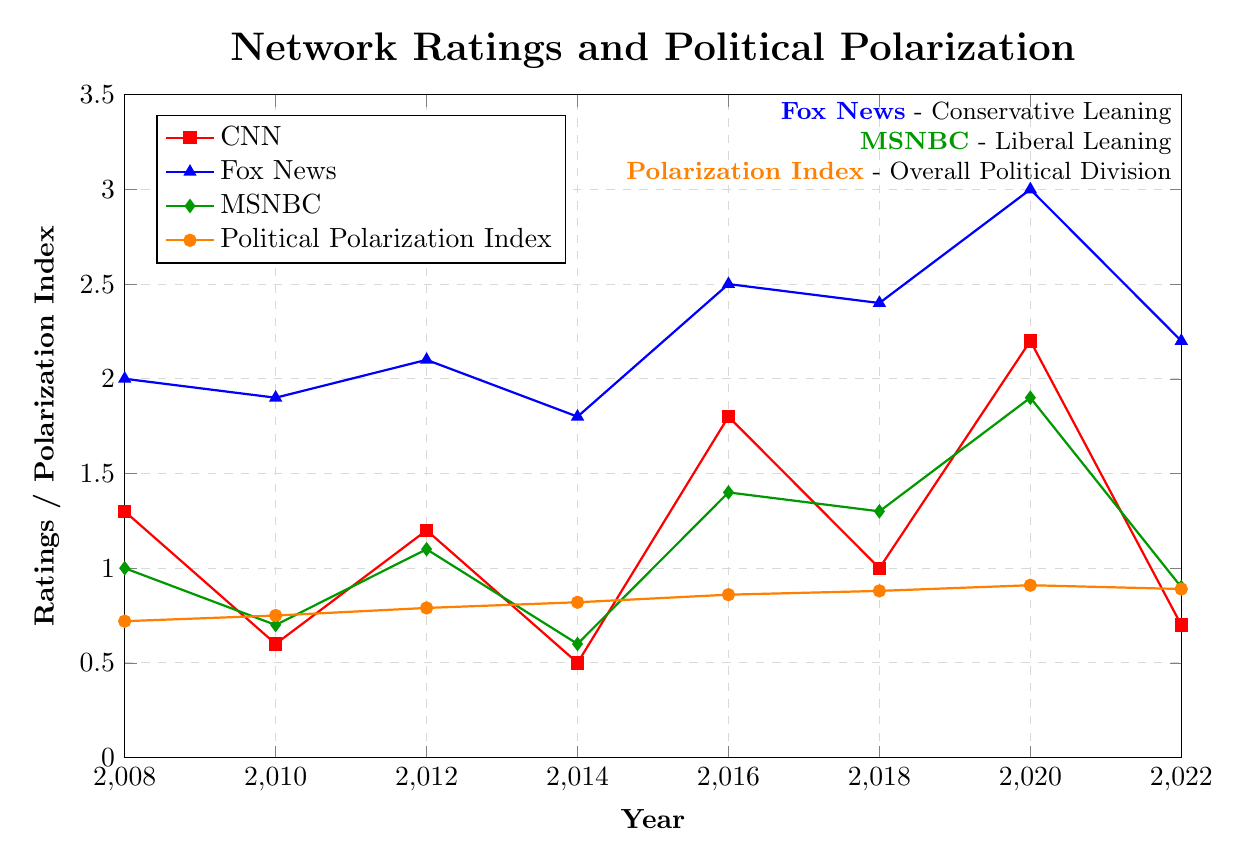What year had the highest CNN rating? By looking at the red line representing CNN in the plot, we notice that the CNN rating peaked in 2020.
Answer: 2020 Which network had the lowest ratings in 2014? Observing the ratings for 2014, CNN (0.5) and MSNBC (0.6) both have low ratings, but CNN's rating is the lowest.
Answer: CNN How does the trend of Fox News ratings compare to the Political Polarization Index? Examining both the blue line for Fox News and the orange line for the Political Polarization Index, both show an increasing trend from 2008 to 2020 with a slight decrease in 2022, indicating a similar upward trajectory.
Answer: Similar upward trend In which year did CNN ratings and MSNBC ratings have the same relative difference as in 2022? Calculate the relative difference between CNN and MSNBC ratings in 2022 (0.7 - 0.9 = -0.2). Then, compare this difference with other years to find that in 2008 (1.3 - 1.0 = 0.3) is close, though not identical. Therefore, 2022 doesn't have an exact match earlier years show a difference.
Answer: No exact match What is the average rating of MSNBC between 2008 and 2018? Summing up MSNBC's ratings from 2008 to 2018: 1.0 + 0.7 + 1.1 + 0.6 + 1.4 + 1.3 = 6.1. There are 6 years, so the average rating is 6.1 / 6 = 1.02.
Answer: 1.02 Which network had the greatest increase in ratings from 2008 to 2020? Calculate the difference in ratings from 2008 to 2020 for each network: CNN (2.2 - 1.3 = 0.9), Fox News (3.0 - 2.0 = 1.0), and MSNBC (1.9 - 1.0 = 0.9). Fox News had the greatest increase of 1.0.
Answer: Fox News How did the Political Polarization Index change from 2016 to 2020? The Political Polarization Index in 2016 was 0.86 and in 2020 it was 0.91. The difference is 0.91 - 0.86 = 0.05, hence the index increased by 0.05.
Answer: Increased by 0.05 In which year did Fox News ratings see the least amount of change compared to the previous election year? Comparing the differences between Fox News ratings in consecutive election years: 2010-2008 (1.9 - 2.0 = -0.1), 2012-2010 (2.1 - 1.9 = 0.2), 2014-2012 (1.8 - 2.1 = -0.3), 2016-2014 (2.5 - 1.8 = 0.7), 2018-2016 (2.4 - 2.5 = -0.1), 2020-2018 (3.0 - 2.4 = 0.6), 2022-2020 (2.2 - 3.0 = -0.8). The smallest change was from 2008 to 2010 (-0.1).
Answer: 2008 to 2010 What is the relationship between network ratings and political polarization from 2008 to 2022? Observing the overall trends, the Political Polarization Index (orange line) shows a generally increasing trend from 0.72 to 0.91 with slight dips matching the increases in network ratings, particularly noticeable with Fox News (blue line) and CNN (red line). This suggests a potential relationship where increasing ratings are somewhat correlated with rising polarization.
Answer: Positive correlation Which network consistently outperformed the others in terms of ratings over the years? Fox News (blue line) consistently has higher ratings across all years compared to CNN (red line) and MSNBC (green line), indicating that it consistently outperformed the other two networks.
Answer: Fox News 